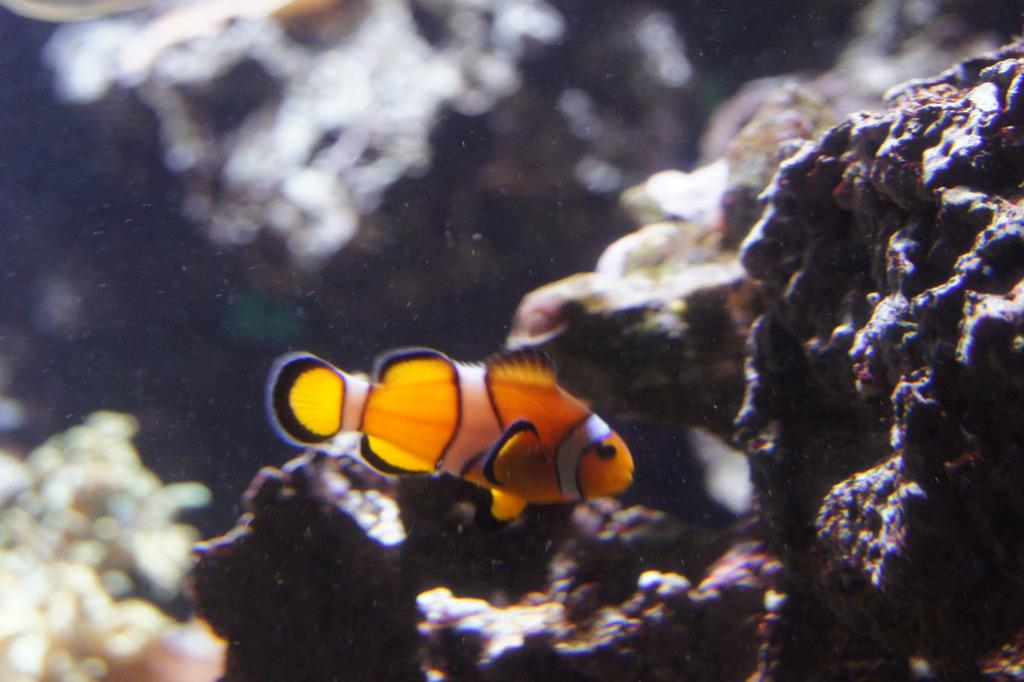What type of animal is in the image? There is a fish in the image. What colors can be seen on the fish? The fish has yellow and black colors. What can be seen in the background of the image? There are stones visible in the background of the image. How would you describe the background of the image? The background of the image appears blurred. What type of patch is the writer wearing on their sleeve in the image? There is no writer or patch present in the image; it features a fish and a blurred background. 